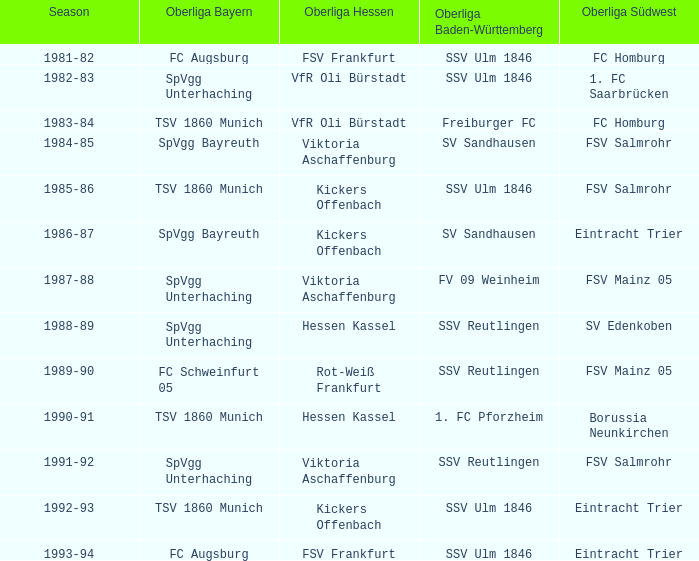Which Season ha spvgg bayreuth and eintracht trier? 1986-87. 